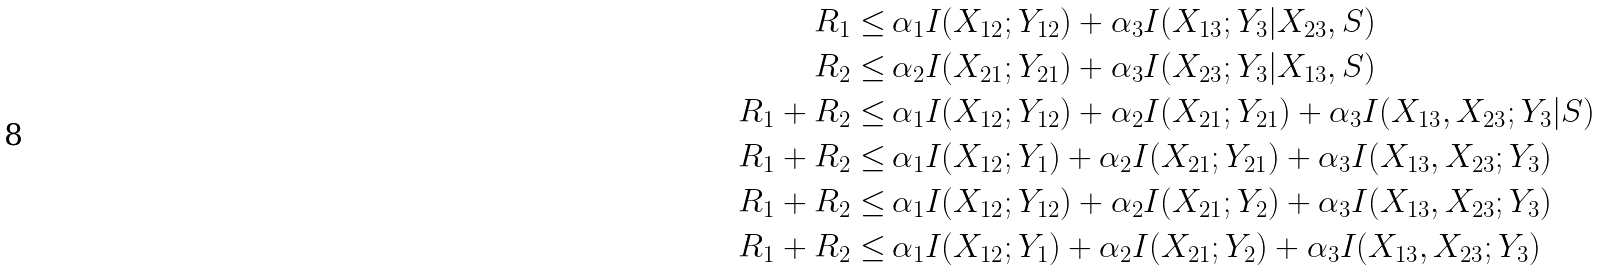Convert formula to latex. <formula><loc_0><loc_0><loc_500><loc_500>R _ { 1 } \leq & \, \alpha _ { 1 } I ( X _ { 1 2 } ; Y _ { 1 2 } ) + \alpha _ { 3 } I ( X _ { 1 3 } ; Y _ { 3 } | X _ { 2 3 } , S ) \\ R _ { 2 } \leq & \, \alpha _ { 2 } I ( X _ { 2 1 } ; Y _ { 2 1 } ) + \alpha _ { 3 } I ( X _ { 2 3 } ; Y _ { 3 } | X _ { 1 3 } , S ) \\ R _ { 1 } + R _ { 2 } \leq & \, \alpha _ { 1 } I ( X _ { 1 2 } ; Y _ { 1 2 } ) + \alpha _ { 2 } I ( X _ { 2 1 } ; Y _ { 2 1 } ) + \alpha _ { 3 } I ( X _ { 1 3 } , X _ { 2 3 } ; Y _ { 3 } | S ) \\ R _ { 1 } + R _ { 2 } \leq & \, \alpha _ { 1 } I ( X _ { 1 2 } ; Y _ { 1 } ) + \alpha _ { 2 } I ( X _ { 2 1 } ; Y _ { 2 1 } ) + \alpha _ { 3 } I ( X _ { 1 3 } , X _ { 2 3 } ; Y _ { 3 } ) \\ R _ { 1 } + R _ { 2 } \leq & \, \alpha _ { 1 } I ( X _ { 1 2 } ; Y _ { 1 2 } ) + \alpha _ { 2 } I ( X _ { 2 1 } ; Y _ { 2 } ) + \alpha _ { 3 } I ( X _ { 1 3 } , X _ { 2 3 } ; Y _ { 3 } ) \\ R _ { 1 } + R _ { 2 } \leq & \, \alpha _ { 1 } I ( X _ { 1 2 } ; Y _ { 1 } ) + \alpha _ { 2 } I ( X _ { 2 1 } ; Y _ { 2 } ) + \alpha _ { 3 } I ( X _ { 1 3 } , X _ { 2 3 } ; Y _ { 3 } )</formula> 